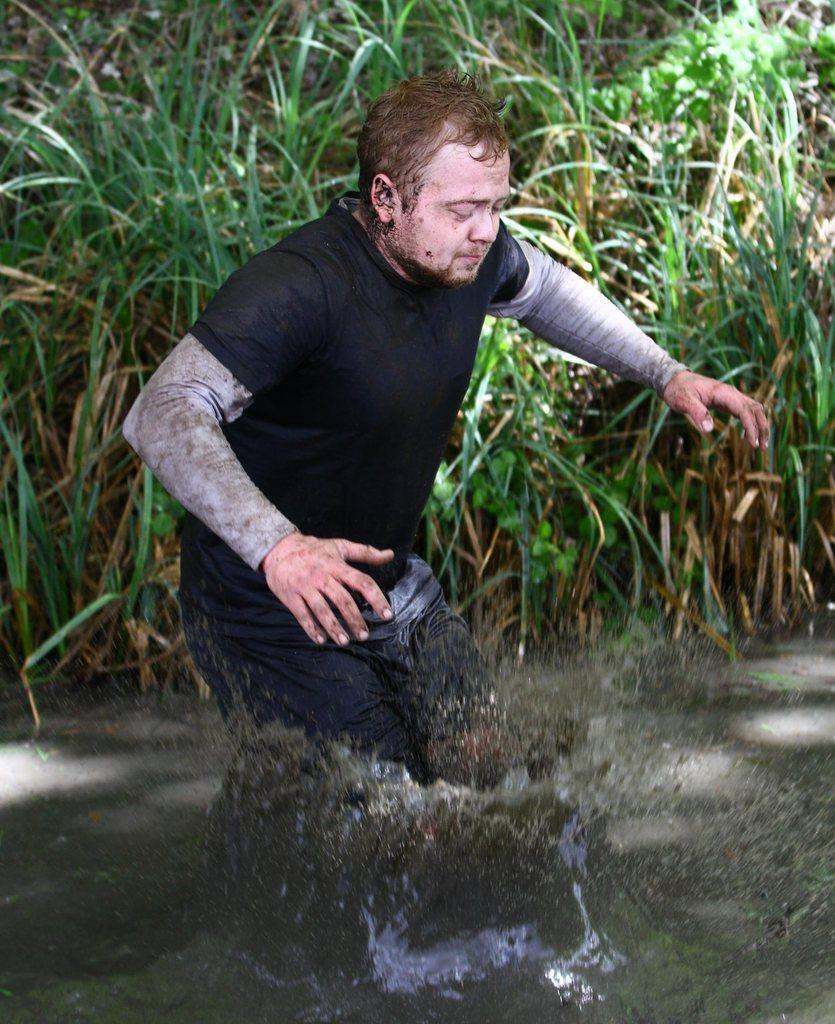Can you describe this image briefly? Here in this picture we can see a man walking in the mud water present over a place and behind him we can see grass and plants present. 